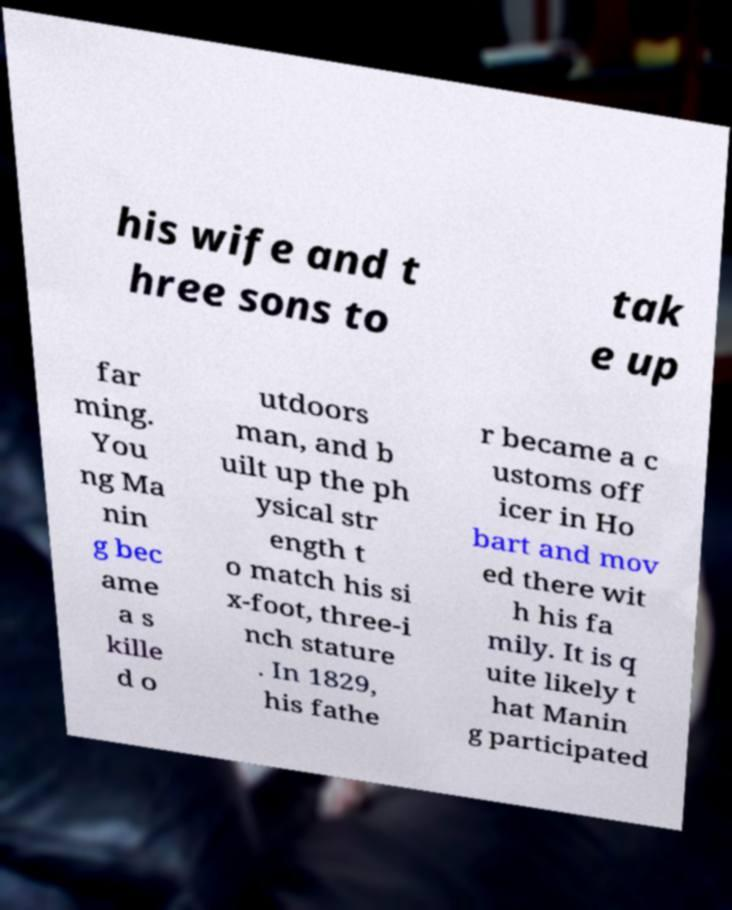I need the written content from this picture converted into text. Can you do that? his wife and t hree sons to tak e up far ming. You ng Ma nin g bec ame a s kille d o utdoors man, and b uilt up the ph ysical str ength t o match his si x-foot, three-i nch stature . In 1829, his fathe r became a c ustoms off icer in Ho bart and mov ed there wit h his fa mily. It is q uite likely t hat Manin g participated 